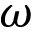Convert formula to latex. <formula><loc_0><loc_0><loc_500><loc_500>\omega</formula> 